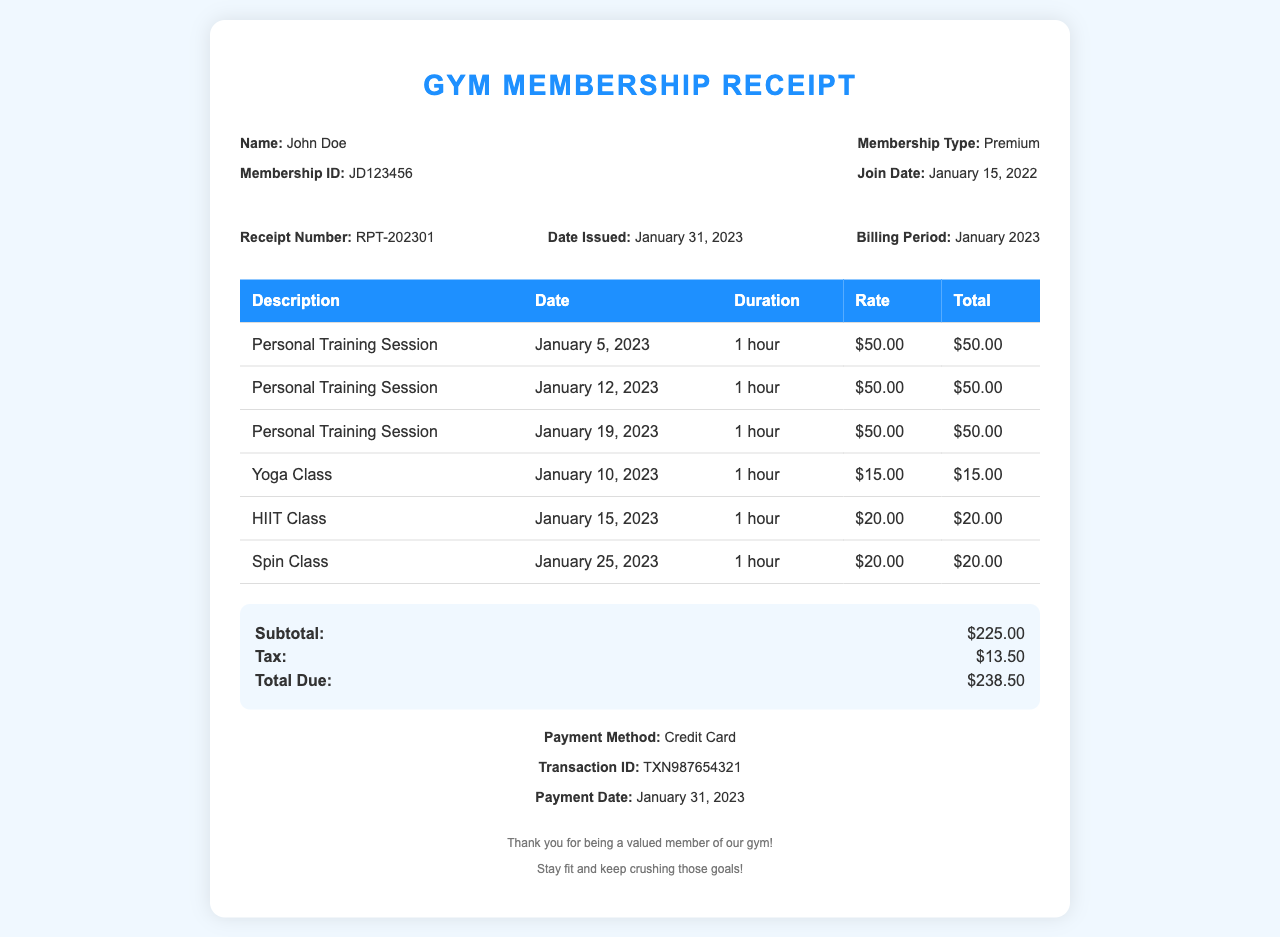what is the membership ID? The membership ID is listed in the member info section of the document as JD123456.
Answer: JD123456 what is the total due amount? The total due amount is calculated as the sum of the subtotal and tax, specified in the summary section.
Answer: $238.50 how many personal training sessions were attended? The document lists three personal training sessions in the table, which are specified under the description column.
Answer: 3 what date was the receipt issued? The receipt issued date is mentioned in the receipt details section as January 31, 2023.
Answer: January 31, 2023 which class was attended on January 10, 2023? The class attended on January 10, 2023, is specified in the table under the date column.
Answer: Yoga Class what is the duration of each personal training session? The duration for each personal training session is consistently stated as 1 hour in the table.
Answer: 1 hour what payment method was used? The payment method is listed in the payment info section of the document.
Answer: Credit Card how much was charged for the Spin Class? The charge for the Spin Class can be found in the total column of the table corresponding to that class entry.
Answer: $20.00 what is the subtotal before tax? The subtotal is detailed in the summary section, which adds up services before tax.
Answer: $225.00 